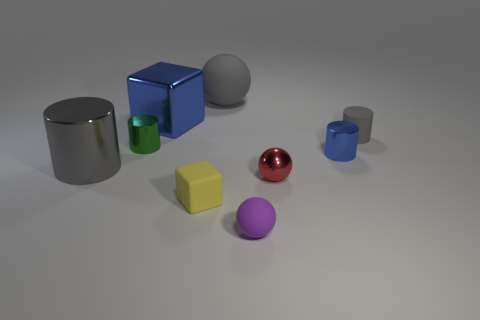Is there a tiny gray metal object of the same shape as the tiny purple object?
Your response must be concise. No. What number of things are large metal objects that are in front of the tiny blue cylinder or big cylinders?
Keep it short and to the point. 1. Are there more small red metallic things that are on the left side of the blue block than small shiny objects that are right of the small purple sphere?
Ensure brevity in your answer.  No. What number of matte things are red things or large red cylinders?
Your answer should be very brief. 0. There is a small object that is the same color as the large cube; what material is it?
Your answer should be compact. Metal. Is the number of blue cubes right of the large blue shiny block less than the number of gray rubber balls that are to the right of the tiny blue metal thing?
Offer a very short reply. No. How many objects are gray spheres or cylinders right of the red shiny object?
Make the answer very short. 3. There is a green object that is the same size as the yellow block; what is it made of?
Your answer should be very brief. Metal. Does the blue cube have the same material as the small purple object?
Your answer should be very brief. No. There is a shiny thing that is both on the left side of the small matte ball and on the right side of the green object; what color is it?
Your answer should be very brief. Blue. 